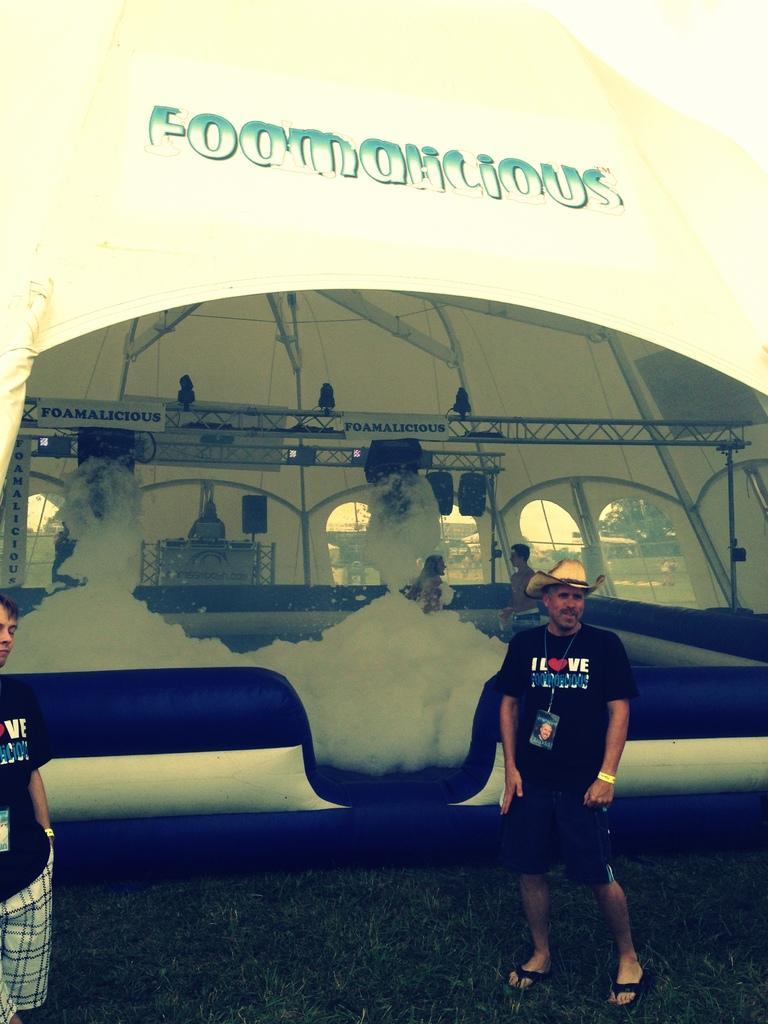Could you give a brief overview of what you see in this image? This picture describes about group of people, on the right side of the image we can see a man, he wore a cap, in the background we can find foam, metal rods, tent and few trees. 